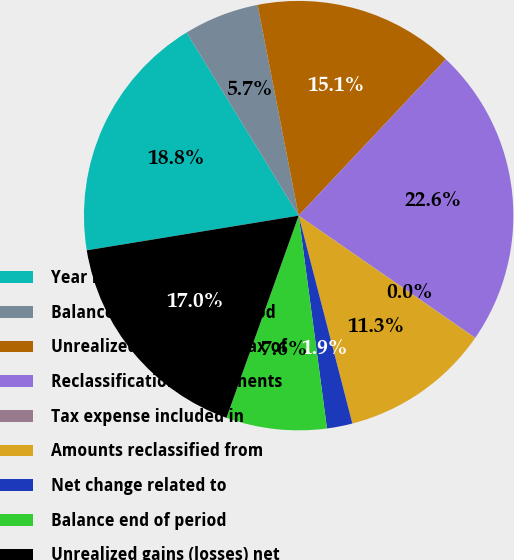Convert chart to OTSL. <chart><loc_0><loc_0><loc_500><loc_500><pie_chart><fcel>Year Ended June 30<fcel>Balance beginning of period<fcel>Unrealized gains net of tax of<fcel>Reclassification adjustments<fcel>Tax expense included in<fcel>Amounts reclassified from<fcel>Net change related to<fcel>Balance end of period<fcel>Unrealized gains (losses) net<nl><fcel>18.84%<fcel>5.68%<fcel>15.08%<fcel>22.6%<fcel>0.04%<fcel>11.32%<fcel>1.92%<fcel>7.56%<fcel>16.96%<nl></chart> 